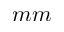Convert formula to latex. <formula><loc_0><loc_0><loc_500><loc_500>m m</formula> 